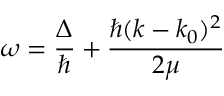<formula> <loc_0><loc_0><loc_500><loc_500>\omega = \frac { \Delta } { } + \frac { \hbar { ( } k - k _ { 0 } ) ^ { 2 } } { 2 \mu }</formula> 